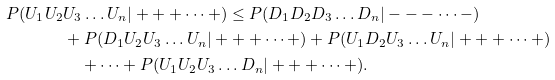Convert formula to latex. <formula><loc_0><loc_0><loc_500><loc_500>P ( U _ { 1 } U _ { 2 } & U _ { 3 } \dots U _ { n } | + + + \dots + ) \leq P ( D _ { 1 } D _ { 2 } D _ { 3 } \dots D _ { n } | - - - \dots - ) \\ & + P ( D _ { 1 } U _ { 2 } U _ { 3 } \dots U _ { n } | + + + \dots + ) + P ( U _ { 1 } D _ { 2 } U _ { 3 } \dots U _ { n } | + + + \dots + ) \\ & \quad + \cdots + P ( U _ { 1 } U _ { 2 } U _ { 3 } \dots D _ { n } | + + + \dots + ) .</formula> 